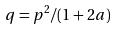<formula> <loc_0><loc_0><loc_500><loc_500>q = p ^ { 2 } / ( 1 + 2 a )</formula> 